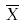Convert formula to latex. <formula><loc_0><loc_0><loc_500><loc_500>\overline { X }</formula> 